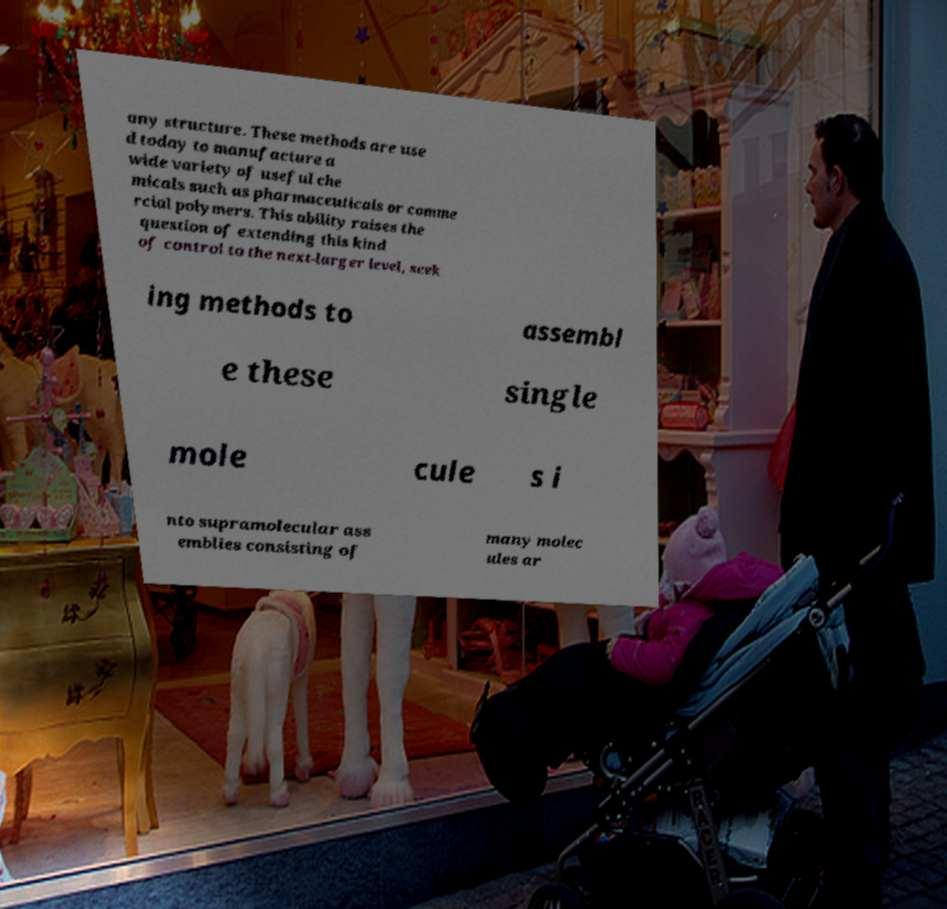For documentation purposes, I need the text within this image transcribed. Could you provide that? any structure. These methods are use d today to manufacture a wide variety of useful che micals such as pharmaceuticals or comme rcial polymers. This ability raises the question of extending this kind of control to the next-larger level, seek ing methods to assembl e these single mole cule s i nto supramolecular ass emblies consisting of many molec ules ar 